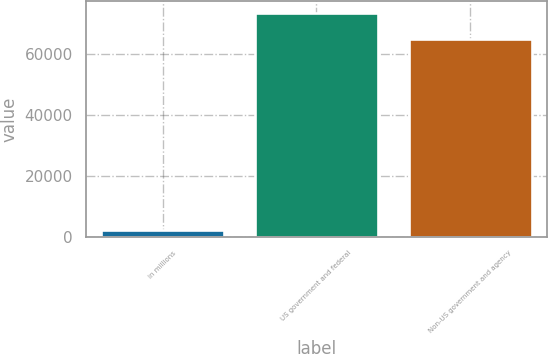Convert chart to OTSL. <chart><loc_0><loc_0><loc_500><loc_500><bar_chart><fcel>in millions<fcel>US government and federal<fcel>Non-US government and agency<nl><fcel>2012<fcel>73477<fcel>64724<nl></chart> 